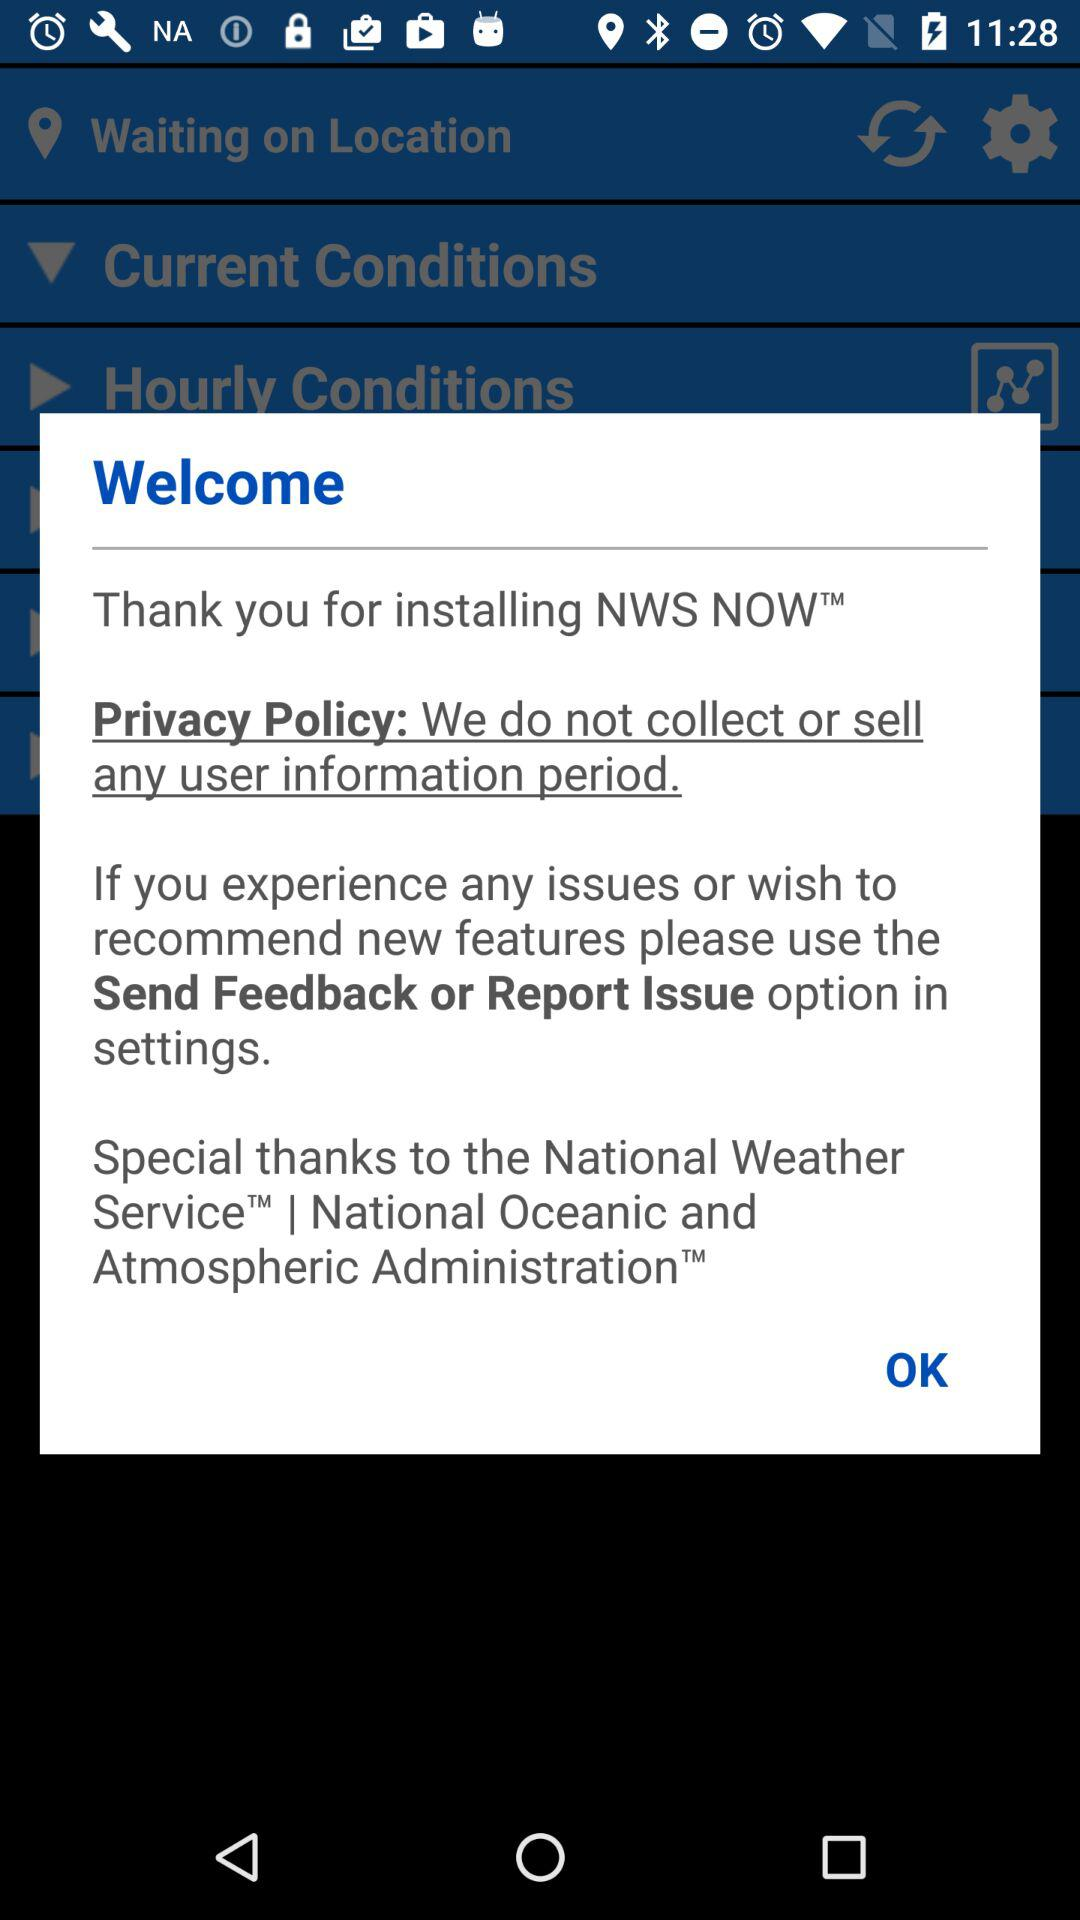What application has been installed? The application that has been installed is "NWS NOW". 